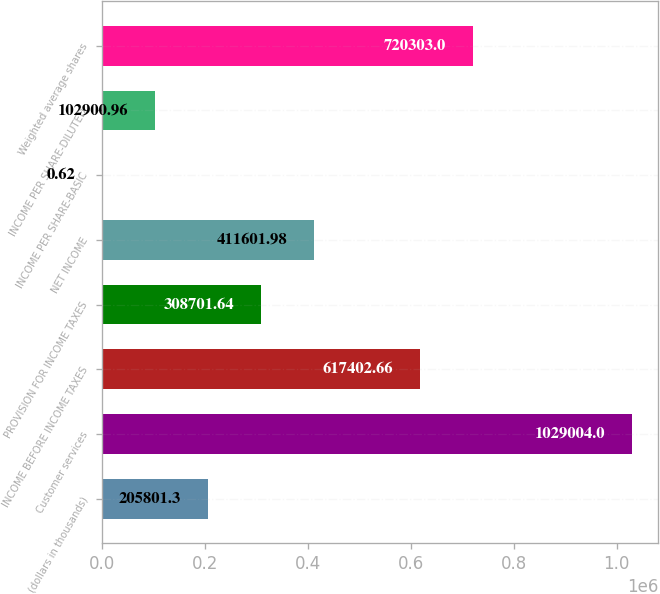Convert chart to OTSL. <chart><loc_0><loc_0><loc_500><loc_500><bar_chart><fcel>(dollars in thousands)<fcel>Customer services<fcel>INCOME BEFORE INCOME TAXES<fcel>PROVISION FOR INCOME TAXES<fcel>NET INCOME<fcel>INCOME PER SHARE-BASIC<fcel>INCOME PER SHARE-DILUTED<fcel>Weighted average shares<nl><fcel>205801<fcel>1.029e+06<fcel>617403<fcel>308702<fcel>411602<fcel>0.62<fcel>102901<fcel>720303<nl></chart> 